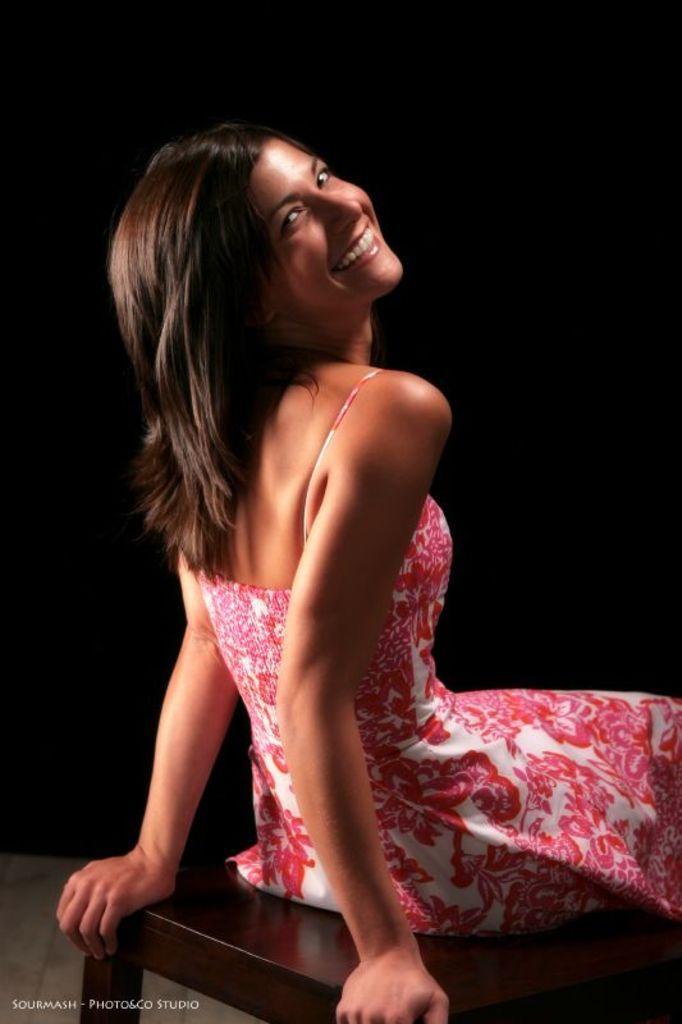Describe this image in one or two sentences. The women wearing pink dress is sitting on a stool and smiling. 